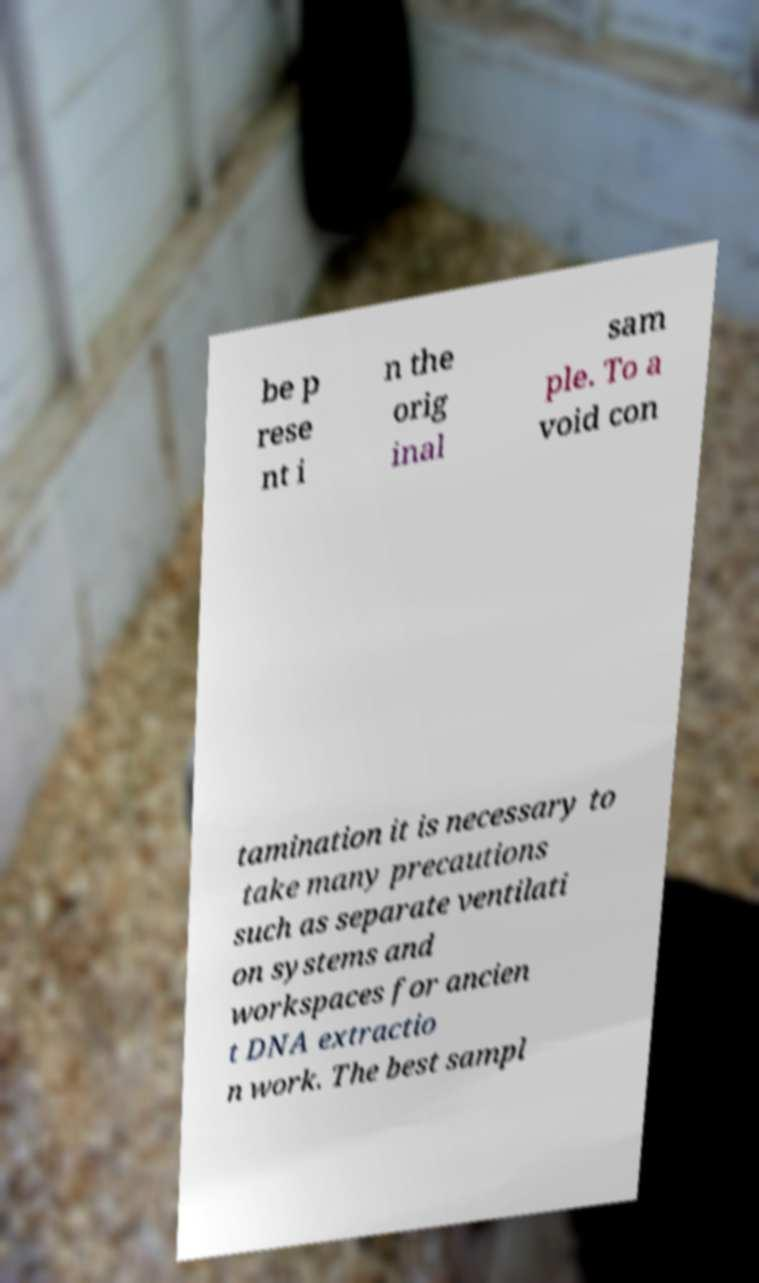Please read and relay the text visible in this image. What does it say? be p rese nt i n the orig inal sam ple. To a void con tamination it is necessary to take many precautions such as separate ventilati on systems and workspaces for ancien t DNA extractio n work. The best sampl 